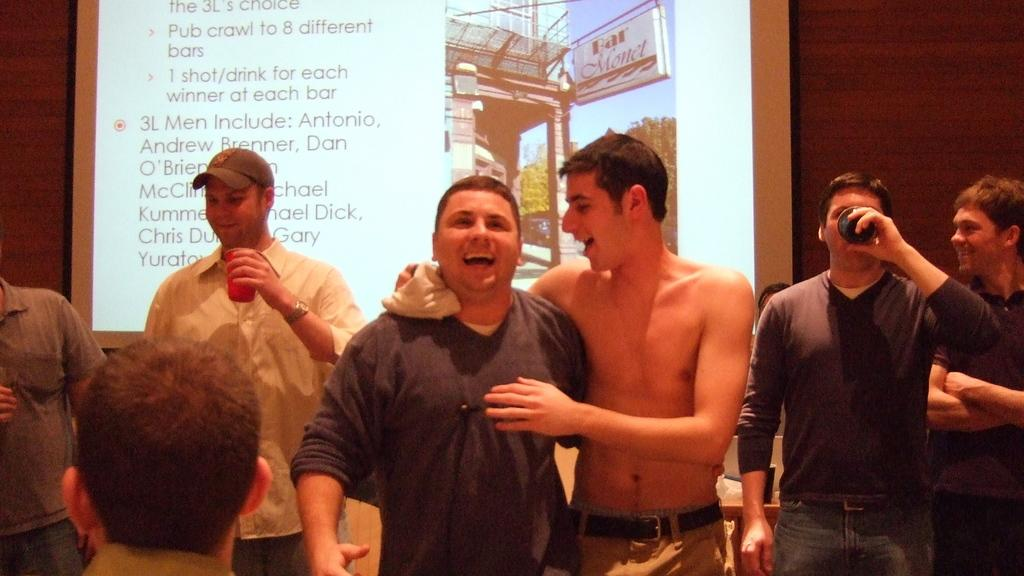How many people are present in the image? There are many people in the image. What are some of the people doing in the image? Some people are holding objects in their hands. What is the large screen in the image used for? There is a projector screen in the image, which is likely used for displaying visuals. What is on the table in the image? There is an object on a table in the image. What type of pizzas are being served at the chess tournament in the image? There is no mention of pizzas or a chess tournament in the image. The image only shows many people, some holding objects, a projector screen, and an object on a table. 